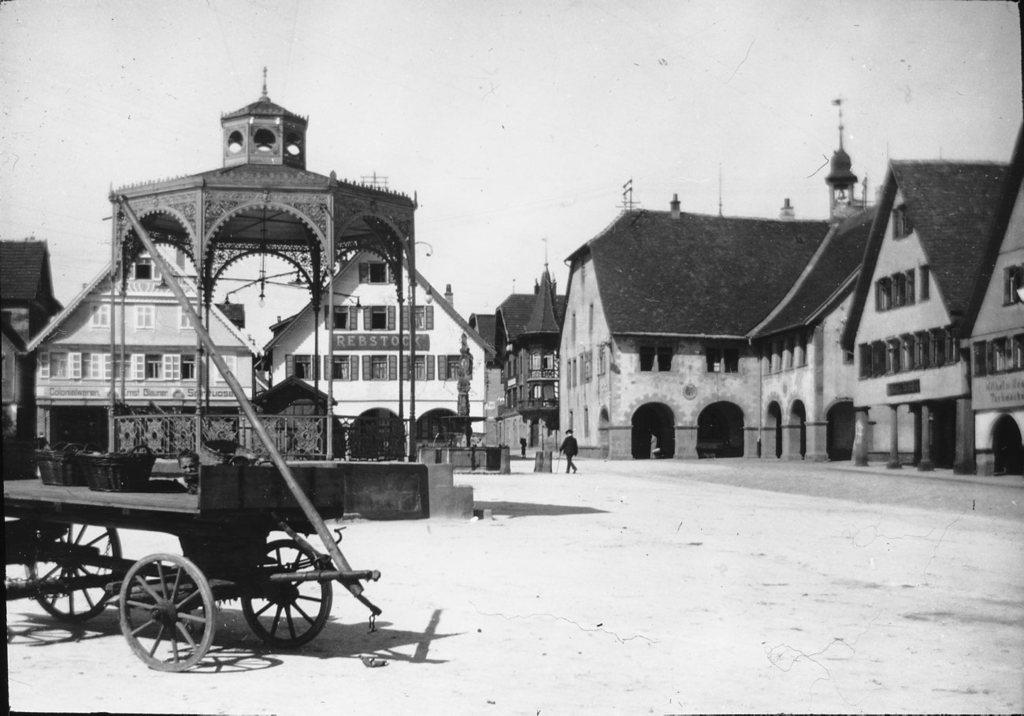What is the main feature of the image? There is a road in the image. What can be seen on the left side of the image? There is a vehicle on the left side of the image. What type of structures are visible in the image? There are buildings visible in the image. What is the person in the image doing? There is a person walking in the image. What is visible at the top of the image? The sky is visible at the top of the image. What type of dinner is the person eating in the image? There is no dinner present in the image; the person is walking. How does the person's stomach feel in the image? There is no information about the person's stomach in the image. 